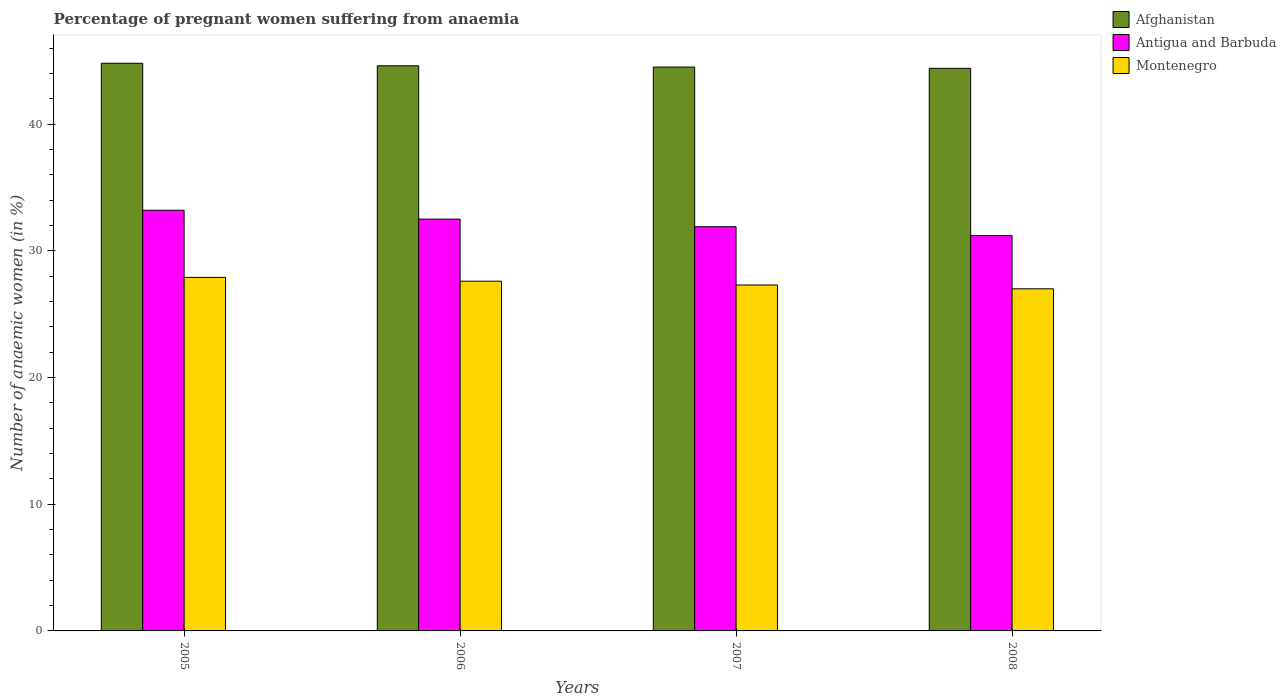Are the number of bars per tick equal to the number of legend labels?
Offer a very short reply. Yes. What is the label of the 2nd group of bars from the left?
Provide a short and direct response. 2006. In how many cases, is the number of bars for a given year not equal to the number of legend labels?
Your answer should be very brief. 0. What is the number of anaemic women in Montenegro in 2005?
Your response must be concise. 27.9. Across all years, what is the maximum number of anaemic women in Montenegro?
Your answer should be very brief. 27.9. What is the total number of anaemic women in Antigua and Barbuda in the graph?
Keep it short and to the point. 128.8. What is the difference between the number of anaemic women in Antigua and Barbuda in 2006 and that in 2007?
Your answer should be very brief. 0.6. What is the difference between the number of anaemic women in Afghanistan in 2008 and the number of anaemic women in Montenegro in 2007?
Your answer should be very brief. 17.1. What is the average number of anaemic women in Afghanistan per year?
Make the answer very short. 44.58. In the year 2008, what is the difference between the number of anaemic women in Afghanistan and number of anaemic women in Montenegro?
Your answer should be very brief. 17.4. In how many years, is the number of anaemic women in Afghanistan greater than 22 %?
Provide a succinct answer. 4. What is the ratio of the number of anaemic women in Antigua and Barbuda in 2007 to that in 2008?
Your answer should be compact. 1.02. Is the difference between the number of anaemic women in Afghanistan in 2007 and 2008 greater than the difference between the number of anaemic women in Montenegro in 2007 and 2008?
Make the answer very short. No. What is the difference between the highest and the second highest number of anaemic women in Montenegro?
Your response must be concise. 0.3. What is the difference between the highest and the lowest number of anaemic women in Montenegro?
Your response must be concise. 0.9. In how many years, is the number of anaemic women in Antigua and Barbuda greater than the average number of anaemic women in Antigua and Barbuda taken over all years?
Give a very brief answer. 2. What does the 3rd bar from the left in 2005 represents?
Provide a short and direct response. Montenegro. What does the 2nd bar from the right in 2008 represents?
Offer a terse response. Antigua and Barbuda. Is it the case that in every year, the sum of the number of anaemic women in Antigua and Barbuda and number of anaemic women in Montenegro is greater than the number of anaemic women in Afghanistan?
Make the answer very short. Yes. Are all the bars in the graph horizontal?
Offer a very short reply. No. How many years are there in the graph?
Give a very brief answer. 4. Are the values on the major ticks of Y-axis written in scientific E-notation?
Provide a short and direct response. No. Does the graph contain grids?
Offer a terse response. No. Where does the legend appear in the graph?
Offer a terse response. Top right. How many legend labels are there?
Give a very brief answer. 3. How are the legend labels stacked?
Your answer should be compact. Vertical. What is the title of the graph?
Keep it short and to the point. Percentage of pregnant women suffering from anaemia. What is the label or title of the X-axis?
Make the answer very short. Years. What is the label or title of the Y-axis?
Provide a succinct answer. Number of anaemic women (in %). What is the Number of anaemic women (in %) in Afghanistan in 2005?
Your response must be concise. 44.8. What is the Number of anaemic women (in %) in Antigua and Barbuda in 2005?
Give a very brief answer. 33.2. What is the Number of anaemic women (in %) of Montenegro in 2005?
Your answer should be compact. 27.9. What is the Number of anaemic women (in %) of Afghanistan in 2006?
Make the answer very short. 44.6. What is the Number of anaemic women (in %) of Antigua and Barbuda in 2006?
Give a very brief answer. 32.5. What is the Number of anaemic women (in %) in Montenegro in 2006?
Keep it short and to the point. 27.6. What is the Number of anaemic women (in %) in Afghanistan in 2007?
Ensure brevity in your answer.  44.5. What is the Number of anaemic women (in %) in Antigua and Barbuda in 2007?
Provide a succinct answer. 31.9. What is the Number of anaemic women (in %) of Montenegro in 2007?
Your answer should be very brief. 27.3. What is the Number of anaemic women (in %) in Afghanistan in 2008?
Ensure brevity in your answer.  44.4. What is the Number of anaemic women (in %) in Antigua and Barbuda in 2008?
Your answer should be very brief. 31.2. What is the Number of anaemic women (in %) in Montenegro in 2008?
Make the answer very short. 27. Across all years, what is the maximum Number of anaemic women (in %) in Afghanistan?
Your answer should be very brief. 44.8. Across all years, what is the maximum Number of anaemic women (in %) in Antigua and Barbuda?
Your response must be concise. 33.2. Across all years, what is the maximum Number of anaemic women (in %) of Montenegro?
Your answer should be very brief. 27.9. Across all years, what is the minimum Number of anaemic women (in %) in Afghanistan?
Provide a succinct answer. 44.4. Across all years, what is the minimum Number of anaemic women (in %) in Antigua and Barbuda?
Make the answer very short. 31.2. Across all years, what is the minimum Number of anaemic women (in %) of Montenegro?
Keep it short and to the point. 27. What is the total Number of anaemic women (in %) in Afghanistan in the graph?
Make the answer very short. 178.3. What is the total Number of anaemic women (in %) of Antigua and Barbuda in the graph?
Provide a succinct answer. 128.8. What is the total Number of anaemic women (in %) in Montenegro in the graph?
Provide a short and direct response. 109.8. What is the difference between the Number of anaemic women (in %) of Afghanistan in 2005 and that in 2006?
Your answer should be compact. 0.2. What is the difference between the Number of anaemic women (in %) of Afghanistan in 2005 and that in 2007?
Your answer should be very brief. 0.3. What is the difference between the Number of anaemic women (in %) of Antigua and Barbuda in 2005 and that in 2008?
Give a very brief answer. 2. What is the difference between the Number of anaemic women (in %) in Afghanistan in 2006 and that in 2007?
Offer a very short reply. 0.1. What is the difference between the Number of anaemic women (in %) of Montenegro in 2006 and that in 2007?
Keep it short and to the point. 0.3. What is the difference between the Number of anaemic women (in %) in Afghanistan in 2006 and that in 2008?
Give a very brief answer. 0.2. What is the difference between the Number of anaemic women (in %) of Antigua and Barbuda in 2007 and that in 2008?
Provide a short and direct response. 0.7. What is the difference between the Number of anaemic women (in %) in Montenegro in 2007 and that in 2008?
Keep it short and to the point. 0.3. What is the difference between the Number of anaemic women (in %) of Afghanistan in 2005 and the Number of anaemic women (in %) of Montenegro in 2006?
Your answer should be compact. 17.2. What is the difference between the Number of anaemic women (in %) of Antigua and Barbuda in 2005 and the Number of anaemic women (in %) of Montenegro in 2006?
Offer a very short reply. 5.6. What is the difference between the Number of anaemic women (in %) of Afghanistan in 2005 and the Number of anaemic women (in %) of Antigua and Barbuda in 2007?
Offer a terse response. 12.9. What is the difference between the Number of anaemic women (in %) of Afghanistan in 2005 and the Number of anaemic women (in %) of Antigua and Barbuda in 2008?
Make the answer very short. 13.6. What is the difference between the Number of anaemic women (in %) in Afghanistan in 2006 and the Number of anaemic women (in %) in Antigua and Barbuda in 2007?
Give a very brief answer. 12.7. What is the difference between the Number of anaemic women (in %) of Afghanistan in 2006 and the Number of anaemic women (in %) of Montenegro in 2007?
Provide a short and direct response. 17.3. What is the difference between the Number of anaemic women (in %) of Afghanistan in 2007 and the Number of anaemic women (in %) of Antigua and Barbuda in 2008?
Ensure brevity in your answer.  13.3. What is the difference between the Number of anaemic women (in %) in Afghanistan in 2007 and the Number of anaemic women (in %) in Montenegro in 2008?
Provide a succinct answer. 17.5. What is the difference between the Number of anaemic women (in %) in Antigua and Barbuda in 2007 and the Number of anaemic women (in %) in Montenegro in 2008?
Provide a short and direct response. 4.9. What is the average Number of anaemic women (in %) in Afghanistan per year?
Your answer should be compact. 44.58. What is the average Number of anaemic women (in %) in Antigua and Barbuda per year?
Give a very brief answer. 32.2. What is the average Number of anaemic women (in %) of Montenegro per year?
Ensure brevity in your answer.  27.45. In the year 2005, what is the difference between the Number of anaemic women (in %) of Antigua and Barbuda and Number of anaemic women (in %) of Montenegro?
Your answer should be very brief. 5.3. In the year 2006, what is the difference between the Number of anaemic women (in %) in Afghanistan and Number of anaemic women (in %) in Antigua and Barbuda?
Ensure brevity in your answer.  12.1. In the year 2007, what is the difference between the Number of anaemic women (in %) of Afghanistan and Number of anaemic women (in %) of Antigua and Barbuda?
Provide a short and direct response. 12.6. In the year 2007, what is the difference between the Number of anaemic women (in %) of Afghanistan and Number of anaemic women (in %) of Montenegro?
Your answer should be compact. 17.2. In the year 2008, what is the difference between the Number of anaemic women (in %) in Afghanistan and Number of anaemic women (in %) in Montenegro?
Keep it short and to the point. 17.4. In the year 2008, what is the difference between the Number of anaemic women (in %) of Antigua and Barbuda and Number of anaemic women (in %) of Montenegro?
Provide a short and direct response. 4.2. What is the ratio of the Number of anaemic women (in %) in Afghanistan in 2005 to that in 2006?
Offer a very short reply. 1. What is the ratio of the Number of anaemic women (in %) of Antigua and Barbuda in 2005 to that in 2006?
Keep it short and to the point. 1.02. What is the ratio of the Number of anaemic women (in %) in Montenegro in 2005 to that in 2006?
Make the answer very short. 1.01. What is the ratio of the Number of anaemic women (in %) in Afghanistan in 2005 to that in 2007?
Your answer should be very brief. 1.01. What is the ratio of the Number of anaemic women (in %) of Antigua and Barbuda in 2005 to that in 2007?
Offer a very short reply. 1.04. What is the ratio of the Number of anaemic women (in %) of Montenegro in 2005 to that in 2007?
Give a very brief answer. 1.02. What is the ratio of the Number of anaemic women (in %) of Antigua and Barbuda in 2005 to that in 2008?
Offer a very short reply. 1.06. What is the ratio of the Number of anaemic women (in %) in Montenegro in 2005 to that in 2008?
Ensure brevity in your answer.  1.03. What is the ratio of the Number of anaemic women (in %) of Afghanistan in 2006 to that in 2007?
Provide a short and direct response. 1. What is the ratio of the Number of anaemic women (in %) of Antigua and Barbuda in 2006 to that in 2007?
Your answer should be very brief. 1.02. What is the ratio of the Number of anaemic women (in %) in Montenegro in 2006 to that in 2007?
Your response must be concise. 1.01. What is the ratio of the Number of anaemic women (in %) of Afghanistan in 2006 to that in 2008?
Offer a terse response. 1. What is the ratio of the Number of anaemic women (in %) of Antigua and Barbuda in 2006 to that in 2008?
Your answer should be very brief. 1.04. What is the ratio of the Number of anaemic women (in %) of Montenegro in 2006 to that in 2008?
Give a very brief answer. 1.02. What is the ratio of the Number of anaemic women (in %) of Afghanistan in 2007 to that in 2008?
Keep it short and to the point. 1. What is the ratio of the Number of anaemic women (in %) in Antigua and Barbuda in 2007 to that in 2008?
Give a very brief answer. 1.02. What is the ratio of the Number of anaemic women (in %) of Montenegro in 2007 to that in 2008?
Ensure brevity in your answer.  1.01. What is the difference between the highest and the second highest Number of anaemic women (in %) in Afghanistan?
Your answer should be compact. 0.2. What is the difference between the highest and the second highest Number of anaemic women (in %) of Antigua and Barbuda?
Make the answer very short. 0.7. What is the difference between the highest and the lowest Number of anaemic women (in %) of Antigua and Barbuda?
Make the answer very short. 2. What is the difference between the highest and the lowest Number of anaemic women (in %) of Montenegro?
Provide a succinct answer. 0.9. 